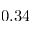Convert formula to latex. <formula><loc_0><loc_0><loc_500><loc_500>0 . 3 4</formula> 